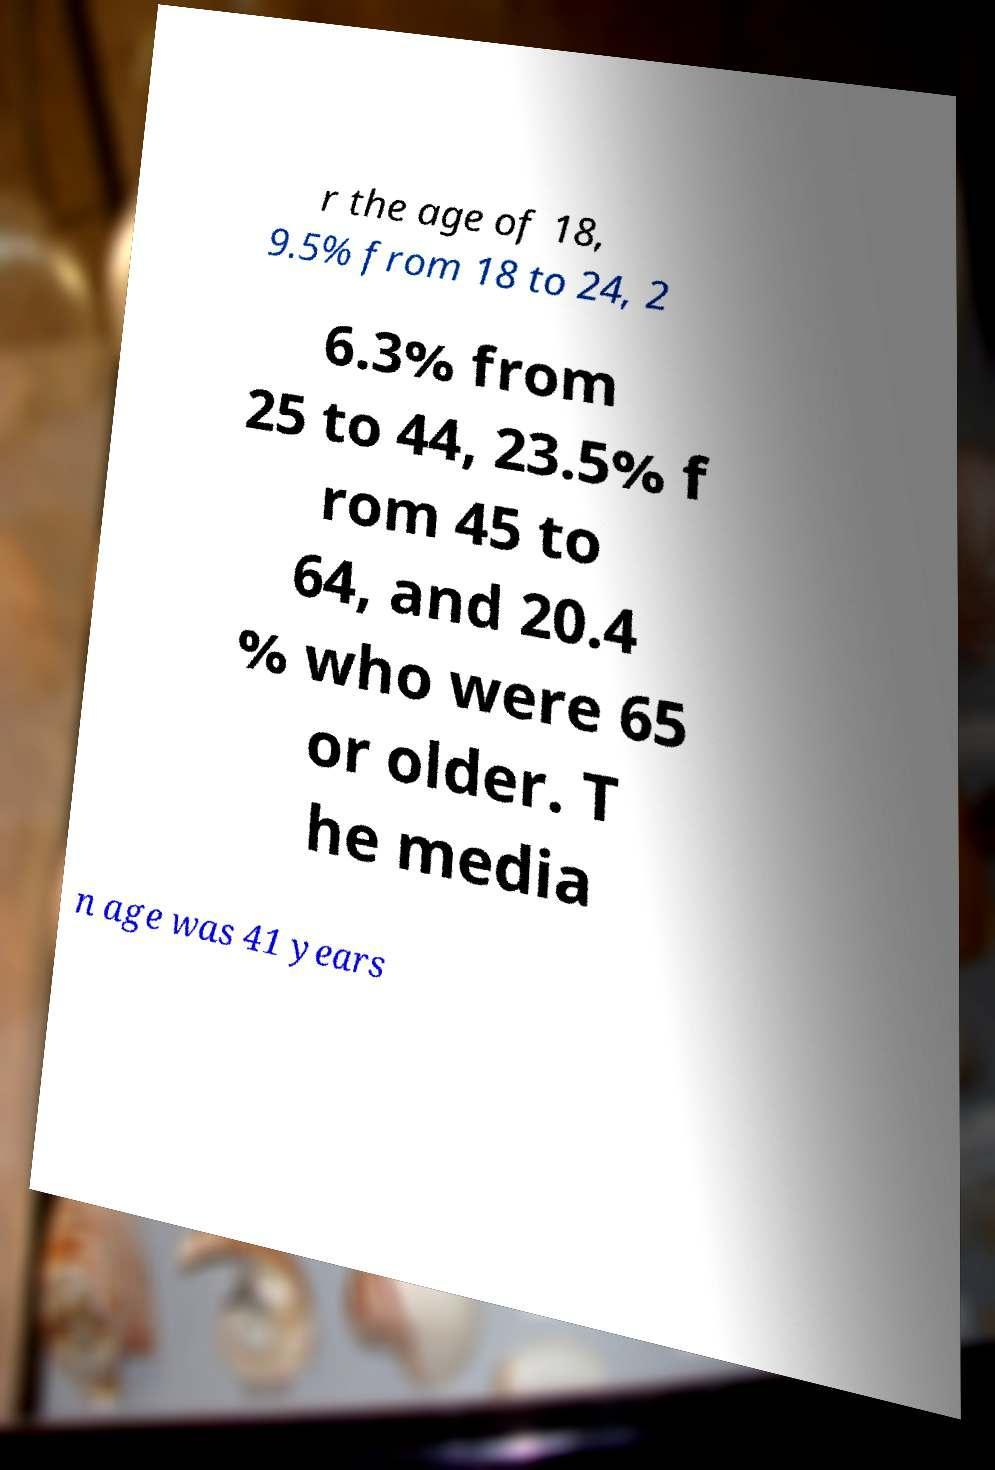I need the written content from this picture converted into text. Can you do that? r the age of 18, 9.5% from 18 to 24, 2 6.3% from 25 to 44, 23.5% f rom 45 to 64, and 20.4 % who were 65 or older. T he media n age was 41 years 